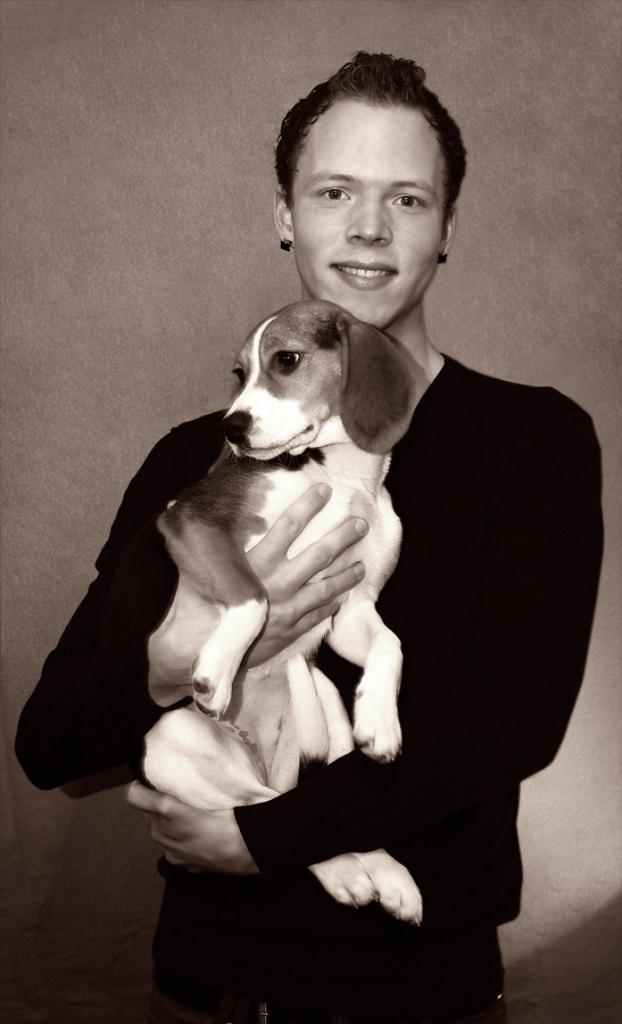What is the main subject of the image? The main subject of the image is a man. Where is the man located in the image? The man is standing in the center of the image. What is the man holding in the image? The man is holding a dog. How is the dog being held by the man? The dog is in the man's hand. What is the man's facial expression in the image? The man is smiling. What type of jam is being spread on the heart in the image? There is no jam or heart present in the image; it features a man holding a dog. 